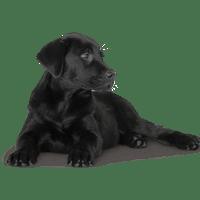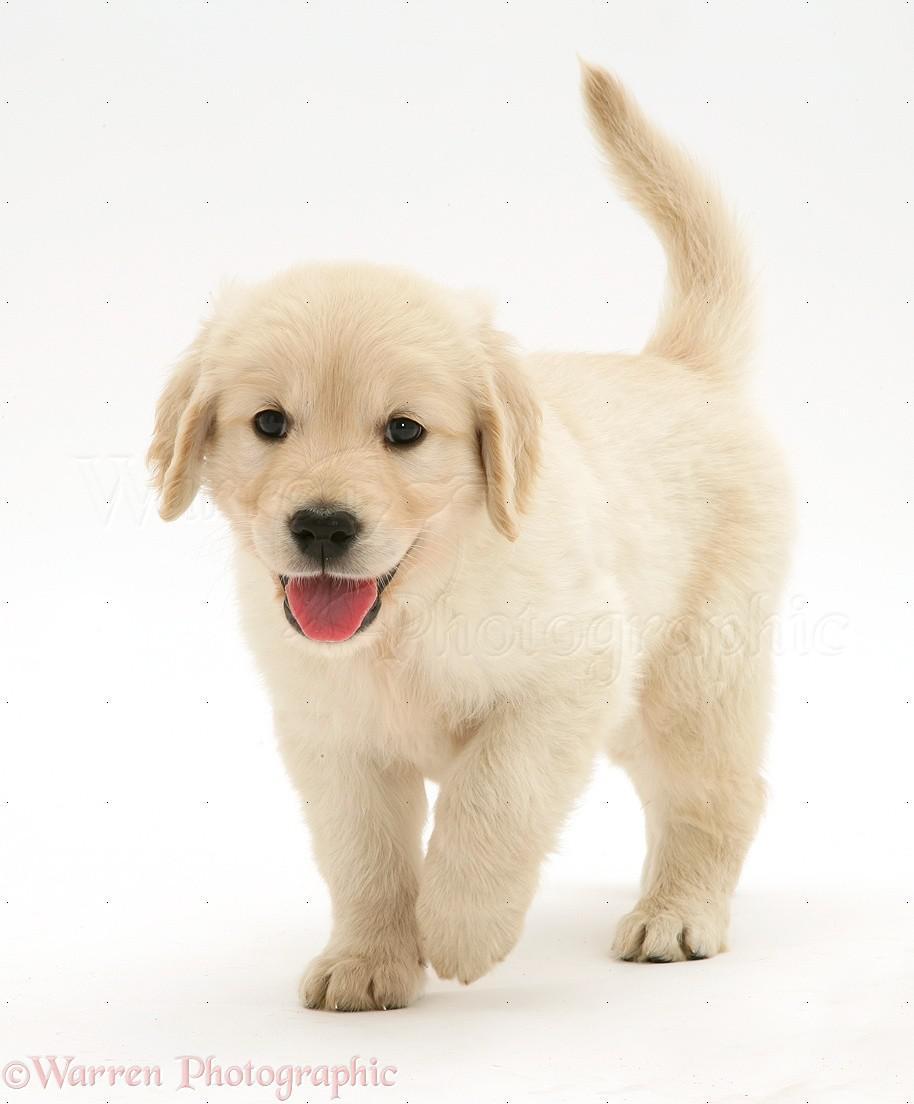The first image is the image on the left, the second image is the image on the right. Analyze the images presented: Is the assertion "An image shows at least one reclining dog wearing something around its neck." valid? Answer yes or no. No. 